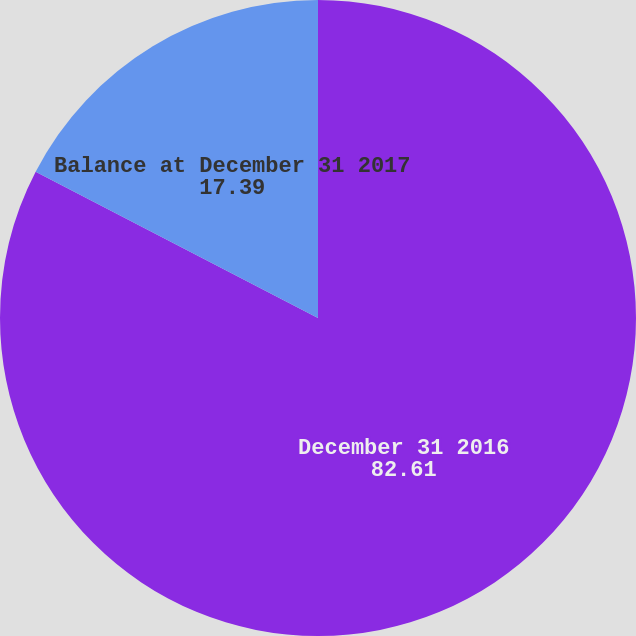Convert chart. <chart><loc_0><loc_0><loc_500><loc_500><pie_chart><fcel>December 31 2016<fcel>Balance at December 31 2017<nl><fcel>82.61%<fcel>17.39%<nl></chart> 